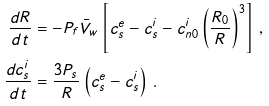<formula> <loc_0><loc_0><loc_500><loc_500>\frac { d R } { d t } & = - P _ { f } \bar { V } _ { w } \left [ c _ { s } ^ { e } - c _ { s } ^ { i } - c _ { n 0 } ^ { i } \left ( \frac { R _ { 0 } } { R } \right ) ^ { 3 } \right ] \, , \\ \frac { d c _ { s } ^ { i } } { d t } & = \frac { 3 P _ { s } } { R } \left ( c _ { s } ^ { e } - c _ { s } ^ { i } \right ) \, .</formula> 